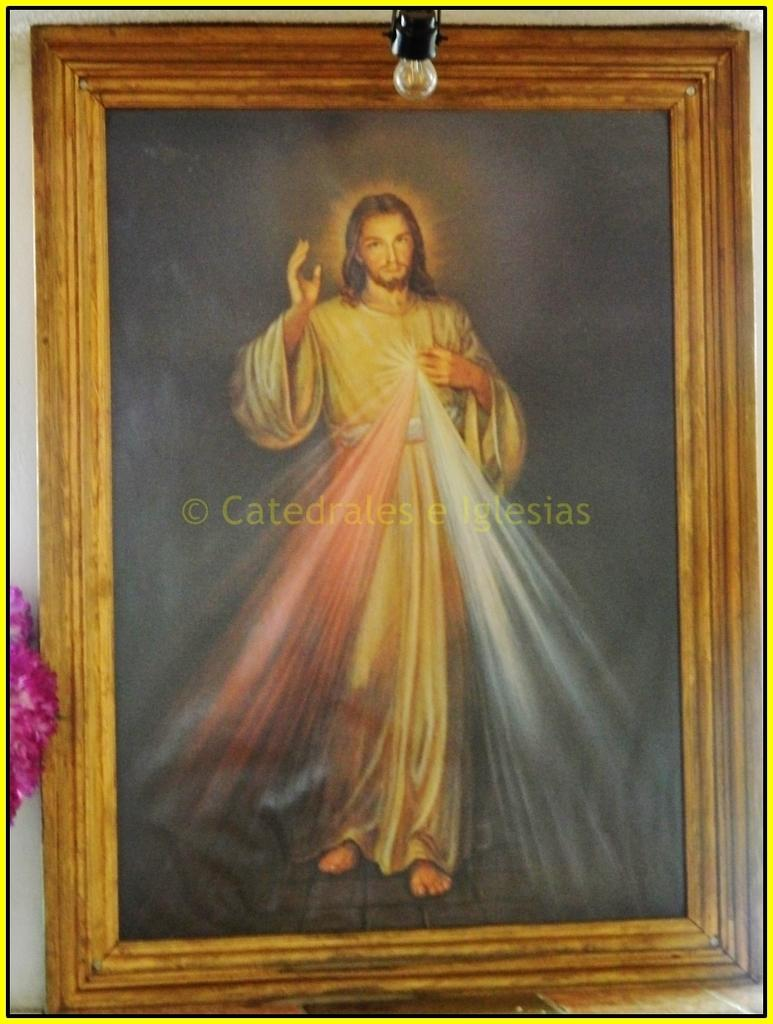Who or what is the main subject in the center of the image? There is a person in the center of the image. What is written or depicted on the frame in the image? There is text on the frame in the image. Can you describe the source of light in the image? There is a light in the image. What type of flora can be seen in the image? There are flowers visible in the image. What type of structure is present in the image? There is a wall in the image. Where are the fairies hiding in the image? There are no fairies present in the image. What is the color of the moon in the image? There is no moon visible in the image. 